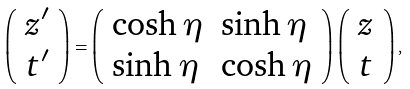Convert formula to latex. <formula><loc_0><loc_0><loc_500><loc_500>\left ( \begin{array} { l } { { z ^ { \prime } } } \\ { { t ^ { \prime } } } \end{array} \right ) = \left ( \begin{array} { l l } { \cosh \eta } & { \sinh \eta } \\ { \sinh \eta } & { \cosh \eta } \end{array} \right ) \left ( \begin{array} { l } { z } \\ { t } \end{array} \right ) ,</formula> 